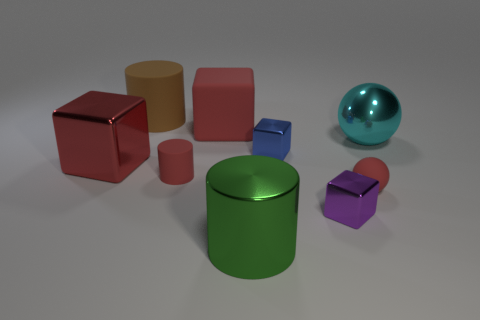Subtract all large red metal cubes. How many cubes are left? 3 Subtract 1 cubes. How many cubes are left? 3 Subtract all green spheres. How many red blocks are left? 2 Subtract all cyan spheres. How many spheres are left? 1 Add 1 big green metallic objects. How many objects exist? 10 Subtract all cubes. How many objects are left? 5 Subtract 0 gray spheres. How many objects are left? 9 Subtract all blue balls. Subtract all blue blocks. How many balls are left? 2 Subtract all large rubber blocks. Subtract all large metal cubes. How many objects are left? 7 Add 5 small purple metal things. How many small purple metal things are left? 6 